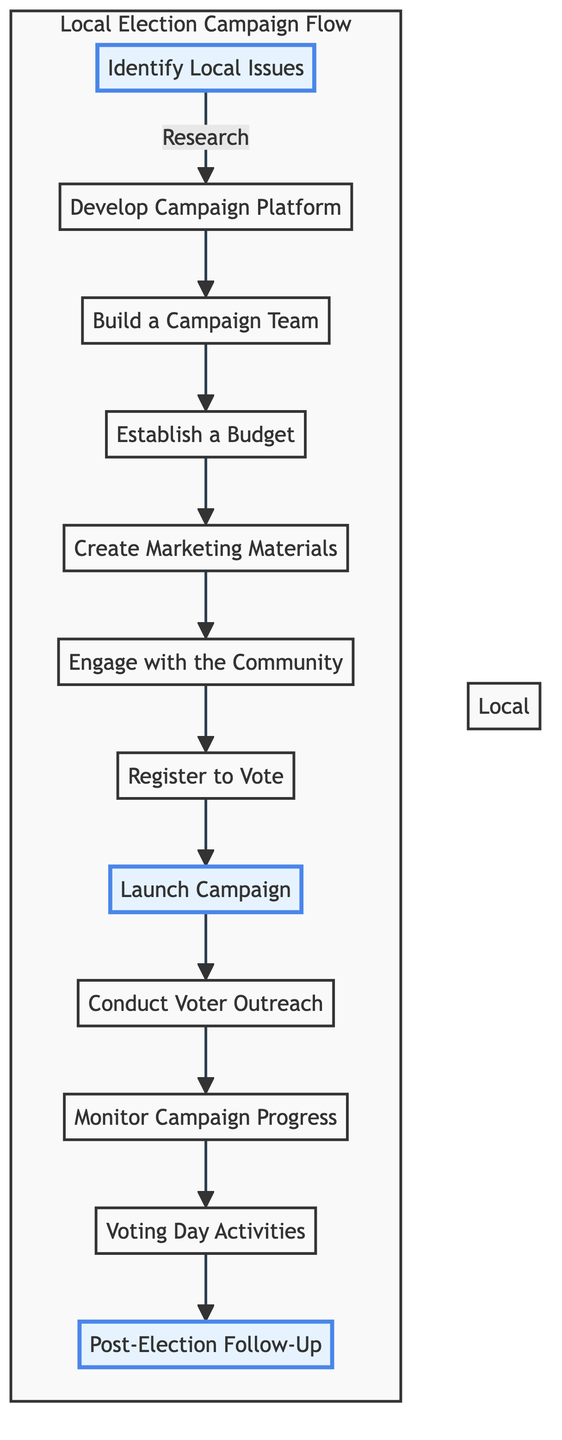What is the first step in the campaign? The first step in the campaign, as indicated by the diagram, is "Identify Local Issues." This follows from the flow chart’s starting point which directly leads to this node.
Answer: Identify Local Issues How many steps are there in total? By counting the nodes in the diagram, we see there are a total of 12 steps representing different phases of the campaign process. Each step corresponds to a key activity in the local election campaign.
Answer: 12 What is the last step outlined in the diagram? The last step in the flow chart is "Post-Election Follow-Up," as it is the final node following "Voting Day Activities." This shows the conclusion of the campaign process.
Answer: Post-Election Follow-Up Which step follows "Launch Campaign"? The step that follows "Launch Campaign" in the sequence is "Conduct Voter Outreach." This progression illustrates the next logical action in executing the campaign.
Answer: Conduct Voter Outreach What step involves designing promotional content? The step that involves designing promotional content is "Create Marketing Materials." This is clearly indicated in the flow between the steps.
Answer: Create Marketing Materials How many steps are highlighted in the chart? There are three highlighted steps in the diagram, which are "Identify Local Issues," "Launch Campaign," and "Post-Election Follow-Up." These emphasize critical transitions in the campaign.
Answer: 3 What is the relationship between "Establish a Budget" and "Create Marketing Materials"? The relationship is sequential; "Establish a Budget" is directly before "Create Marketing Materials," indicating that budgeting must occur prior to creating the materials for the campaign.
Answer: Sequential relationship What action must be taken after "Engage with the Community"? The action that must be taken after "Engage with the Community" is "Register to Vote." This showcases the importance of community engagement as a precursor to voter registration efforts.
Answer: Register to Vote Which steps are part of the campaign's purpose to connect with voters? The steps that are part of the campaign's purpose to connect with voters are "Engage with the Community," "Register to Vote," and "Conduct Voter Outreach," collectively showing different ways a campaign reaches voters.
Answer: Engage with the Community, Register to Vote, Conduct Voter Outreach 